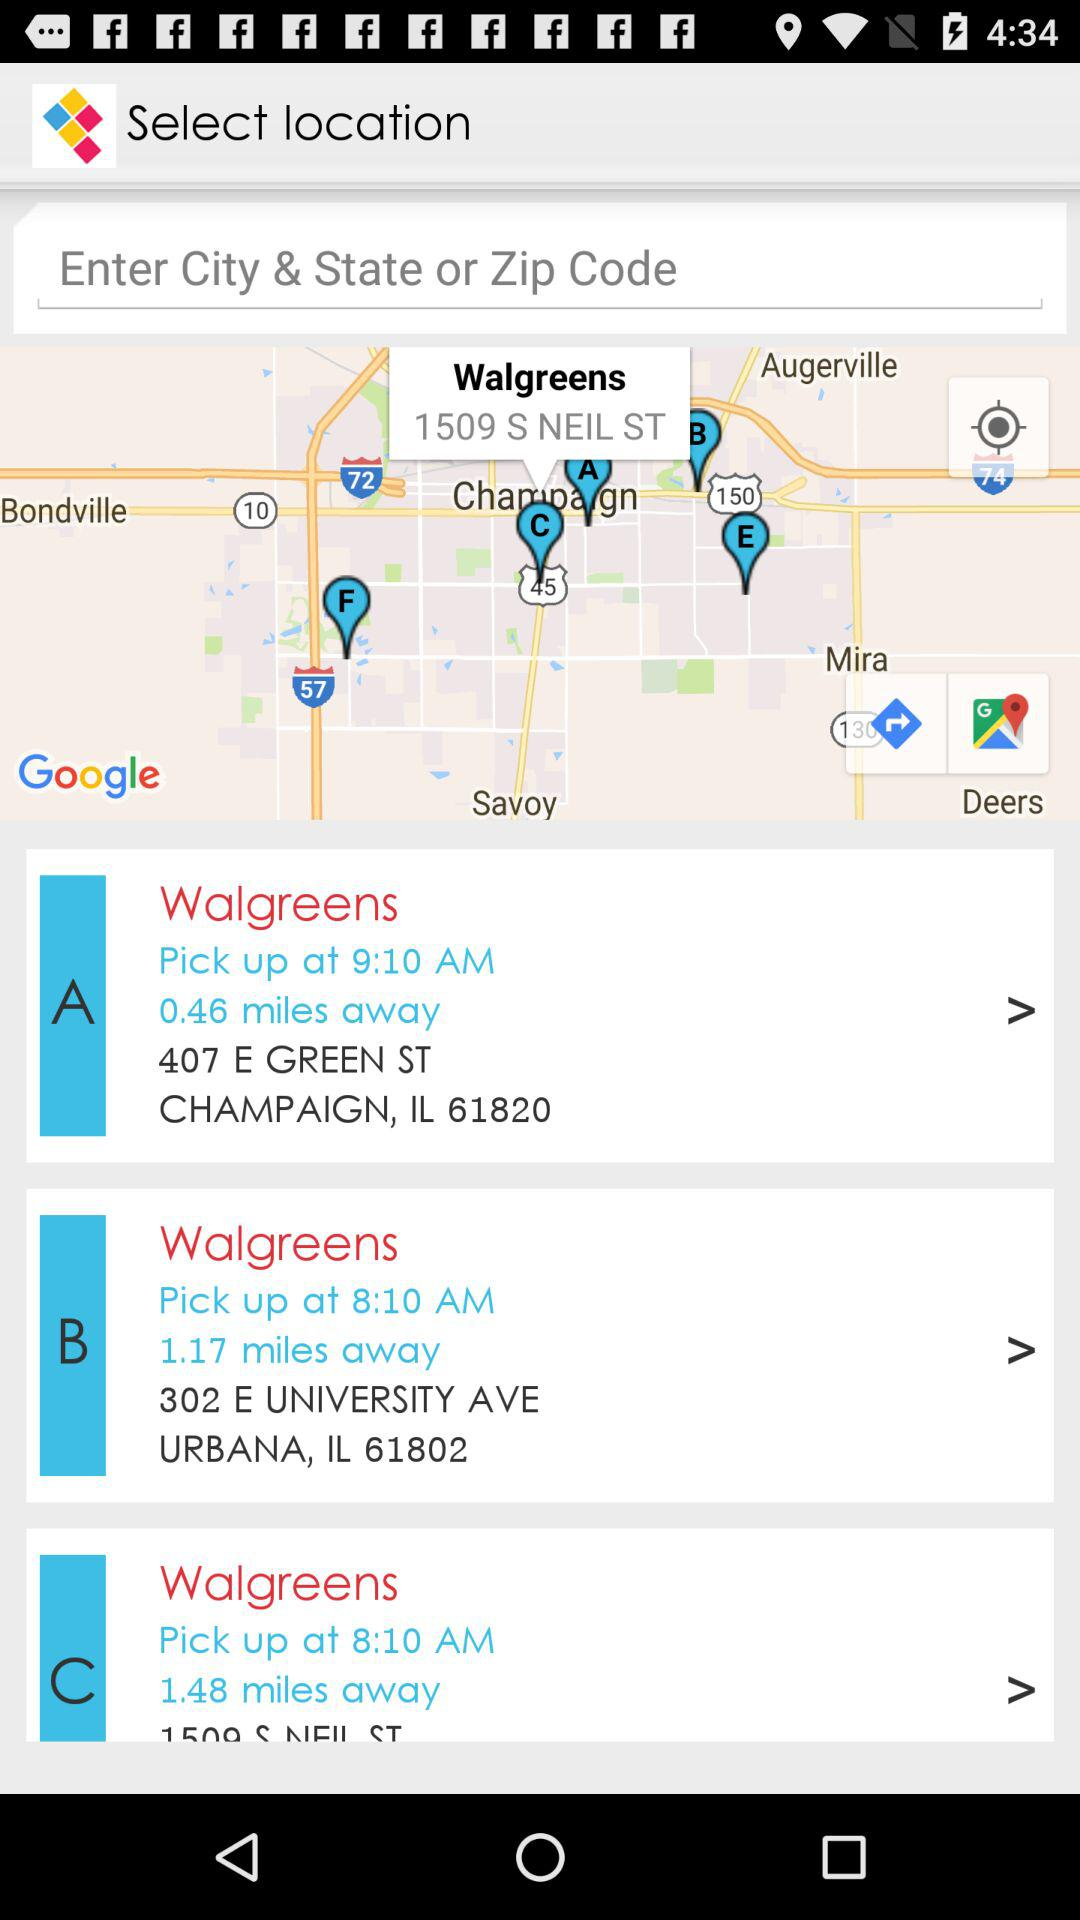What is the distance between the current location of the user and option "C"? The distance between the current location of the user and option "C" is 1.48 miles. 